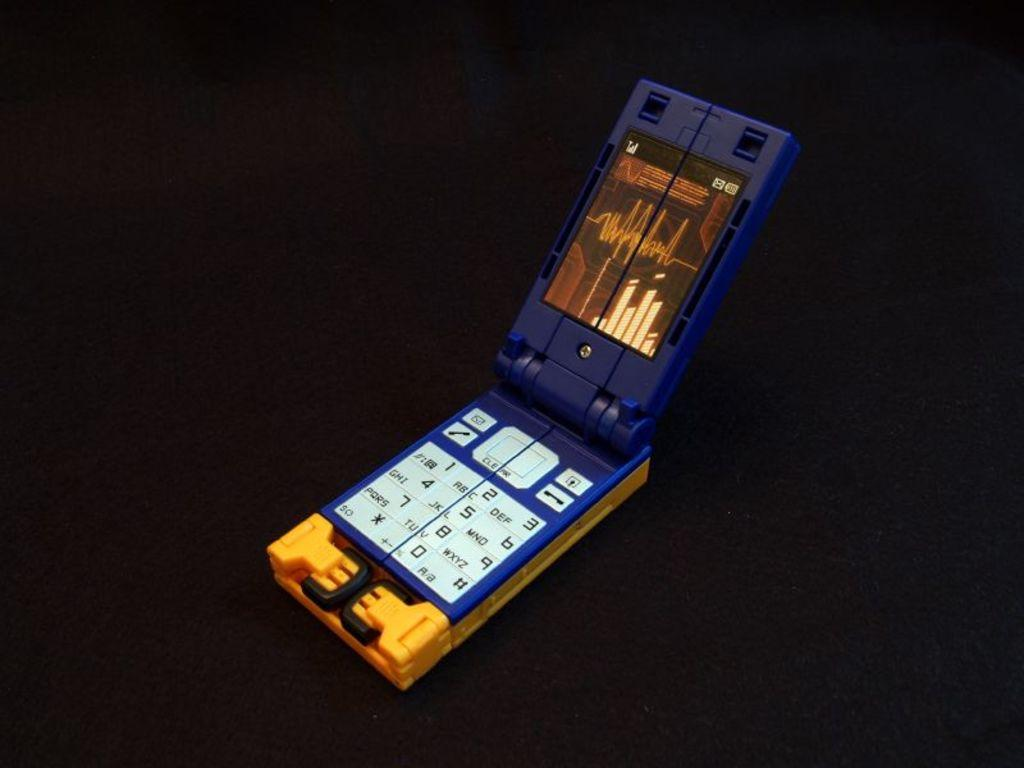<image>
Present a compact description of the photo's key features. The 1 is next to the 2 on the blue phone 